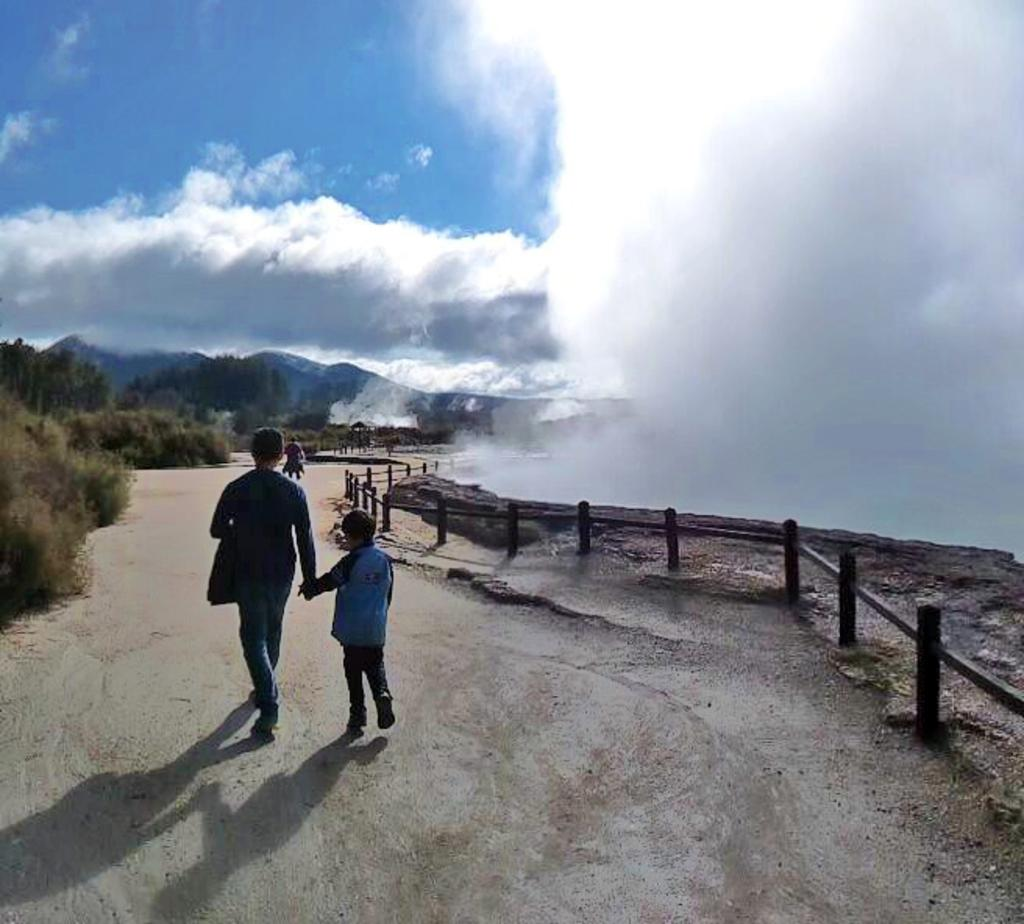Who or what can be seen in the image? There are people in the image. What is the purpose of the fence in the image? The fence serves as a barrier or boundary in the image. What type of vegetation is present in the image? There are plants in the image. What can be seen in the distance in the image? There is a hill visible in the background of the image. What other natural elements can be seen in the background of the image? Trees are present in the background of the image, and the sky is visible with clouds. Where is the shelf located in the image? There is no shelf present in the image. Can you describe the behavior of the squirrel in the image? There is no squirrel present in the image. 